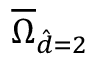<formula> <loc_0><loc_0><loc_500><loc_500>\overline { \Omega } _ { \hat { d } = 2 }</formula> 